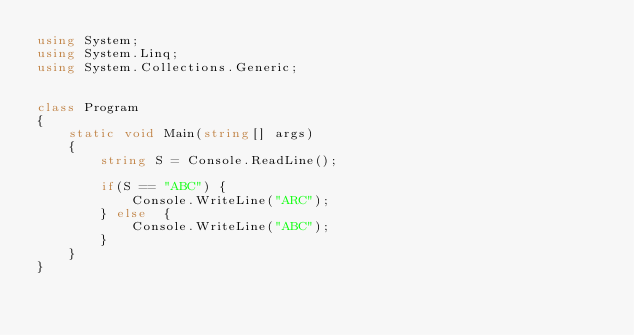Convert code to text. <code><loc_0><loc_0><loc_500><loc_500><_C#_>using System;
using System.Linq;
using System.Collections.Generic;
    
    
class Program
{
    static void Main(string[] args)
    {
        string S = Console.ReadLine();

        if(S == "ABC") {
            Console.WriteLine("ARC");
        } else  {
            Console.WriteLine("ABC");
        }
    }
}</code> 